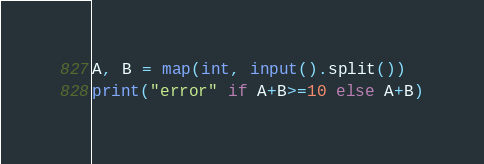Convert code to text. <code><loc_0><loc_0><loc_500><loc_500><_Python_>A, B = map(int, input().split())
print("error" if A+B>=10 else A+B)</code> 